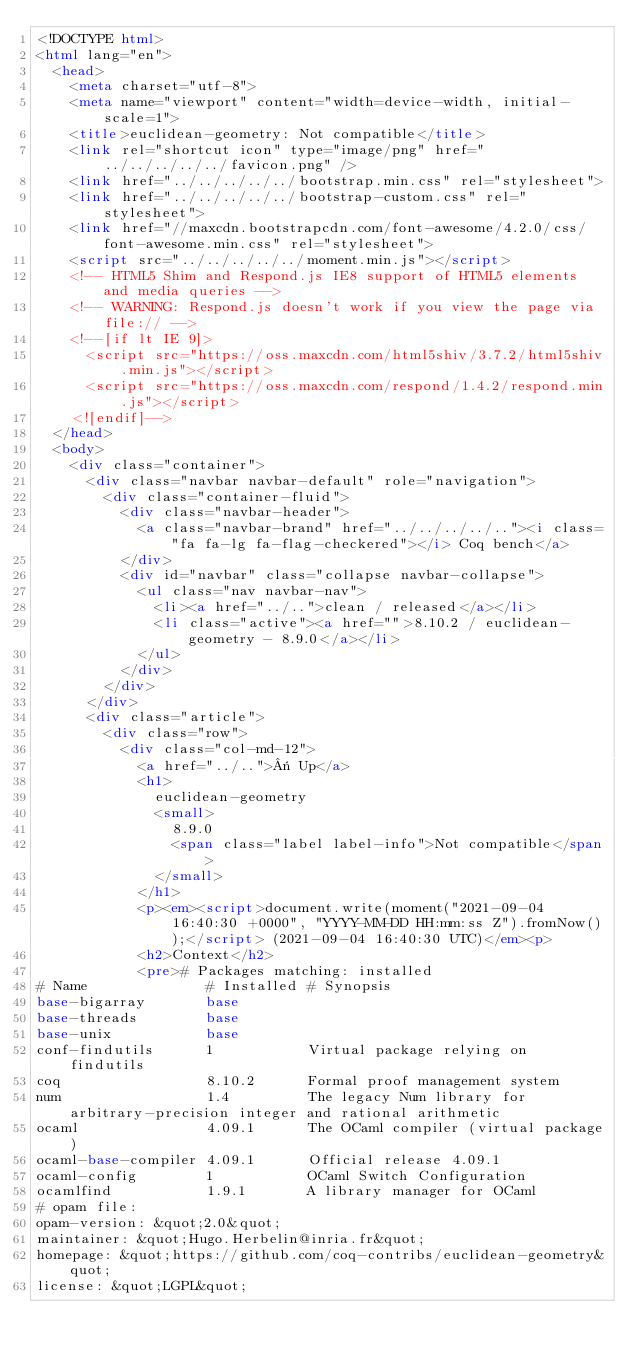<code> <loc_0><loc_0><loc_500><loc_500><_HTML_><!DOCTYPE html>
<html lang="en">
  <head>
    <meta charset="utf-8">
    <meta name="viewport" content="width=device-width, initial-scale=1">
    <title>euclidean-geometry: Not compatible</title>
    <link rel="shortcut icon" type="image/png" href="../../../../../favicon.png" />
    <link href="../../../../../bootstrap.min.css" rel="stylesheet">
    <link href="../../../../../bootstrap-custom.css" rel="stylesheet">
    <link href="//maxcdn.bootstrapcdn.com/font-awesome/4.2.0/css/font-awesome.min.css" rel="stylesheet">
    <script src="../../../../../moment.min.js"></script>
    <!-- HTML5 Shim and Respond.js IE8 support of HTML5 elements and media queries -->
    <!-- WARNING: Respond.js doesn't work if you view the page via file:// -->
    <!--[if lt IE 9]>
      <script src="https://oss.maxcdn.com/html5shiv/3.7.2/html5shiv.min.js"></script>
      <script src="https://oss.maxcdn.com/respond/1.4.2/respond.min.js"></script>
    <![endif]-->
  </head>
  <body>
    <div class="container">
      <div class="navbar navbar-default" role="navigation">
        <div class="container-fluid">
          <div class="navbar-header">
            <a class="navbar-brand" href="../../../../.."><i class="fa fa-lg fa-flag-checkered"></i> Coq bench</a>
          </div>
          <div id="navbar" class="collapse navbar-collapse">
            <ul class="nav navbar-nav">
              <li><a href="../..">clean / released</a></li>
              <li class="active"><a href="">8.10.2 / euclidean-geometry - 8.9.0</a></li>
            </ul>
          </div>
        </div>
      </div>
      <div class="article">
        <div class="row">
          <div class="col-md-12">
            <a href="../..">« Up</a>
            <h1>
              euclidean-geometry
              <small>
                8.9.0
                <span class="label label-info">Not compatible</span>
              </small>
            </h1>
            <p><em><script>document.write(moment("2021-09-04 16:40:30 +0000", "YYYY-MM-DD HH:mm:ss Z").fromNow());</script> (2021-09-04 16:40:30 UTC)</em><p>
            <h2>Context</h2>
            <pre># Packages matching: installed
# Name              # Installed # Synopsis
base-bigarray       base
base-threads        base
base-unix           base
conf-findutils      1           Virtual package relying on findutils
coq                 8.10.2      Formal proof management system
num                 1.4         The legacy Num library for arbitrary-precision integer and rational arithmetic
ocaml               4.09.1      The OCaml compiler (virtual package)
ocaml-base-compiler 4.09.1      Official release 4.09.1
ocaml-config        1           OCaml Switch Configuration
ocamlfind           1.9.1       A library manager for OCaml
# opam file:
opam-version: &quot;2.0&quot;
maintainer: &quot;Hugo.Herbelin@inria.fr&quot;
homepage: &quot;https://github.com/coq-contribs/euclidean-geometry&quot;
license: &quot;LGPL&quot;</code> 